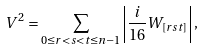Convert formula to latex. <formula><loc_0><loc_0><loc_500><loc_500>V ^ { 2 } = \sum _ { 0 \leq r < s < t \leq n - 1 } \left | \frac { i } { 1 6 } W _ { [ r s t ] } \right | ,</formula> 